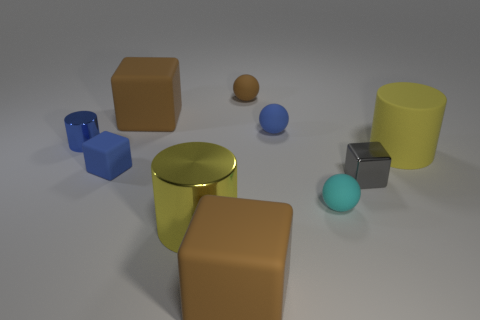How many objects are either big brown cylinders or tiny objects right of the small metallic cylinder?
Offer a terse response. 5. Are there more tiny blue rubber objects than small gray shiny objects?
Make the answer very short. Yes. There is a blue rubber object on the right side of the tiny blue rubber cube; what shape is it?
Your answer should be compact. Sphere. How many other small rubber things are the same shape as the tiny brown object?
Keep it short and to the point. 2. There is a blue rubber thing right of the brown object in front of the blue rubber cube; how big is it?
Provide a succinct answer. Small. How many gray things are big metallic cubes or metallic cubes?
Provide a short and direct response. 1. Is the number of large brown blocks to the left of the blue rubber cube less than the number of blue metal objects that are in front of the gray shiny object?
Make the answer very short. No. There is a gray metal cube; is its size the same as the brown object in front of the big shiny object?
Provide a short and direct response. No. How many other blue matte blocks are the same size as the blue matte block?
Provide a short and direct response. 0. How many tiny objects are gray blocks or blue objects?
Provide a short and direct response. 4. 